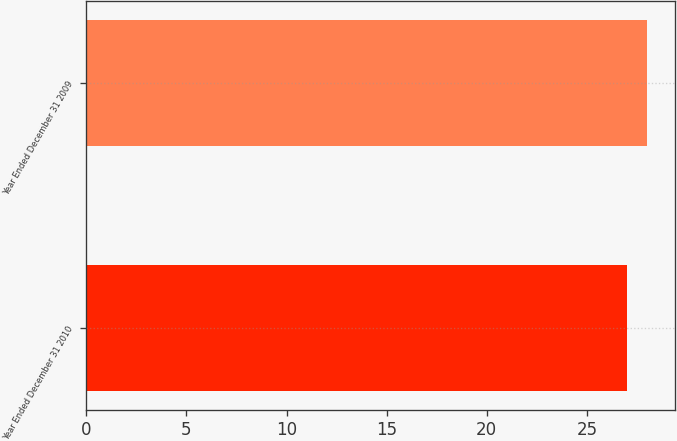Convert chart to OTSL. <chart><loc_0><loc_0><loc_500><loc_500><bar_chart><fcel>Year Ended December 31 2010<fcel>Year Ended December 31 2009<nl><fcel>27<fcel>28<nl></chart> 